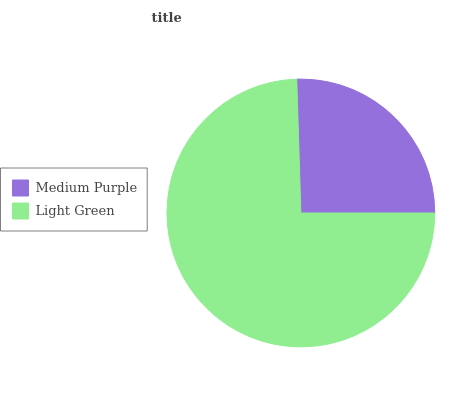Is Medium Purple the minimum?
Answer yes or no. Yes. Is Light Green the maximum?
Answer yes or no. Yes. Is Light Green the minimum?
Answer yes or no. No. Is Light Green greater than Medium Purple?
Answer yes or no. Yes. Is Medium Purple less than Light Green?
Answer yes or no. Yes. Is Medium Purple greater than Light Green?
Answer yes or no. No. Is Light Green less than Medium Purple?
Answer yes or no. No. Is Light Green the high median?
Answer yes or no. Yes. Is Medium Purple the low median?
Answer yes or no. Yes. Is Medium Purple the high median?
Answer yes or no. No. Is Light Green the low median?
Answer yes or no. No. 